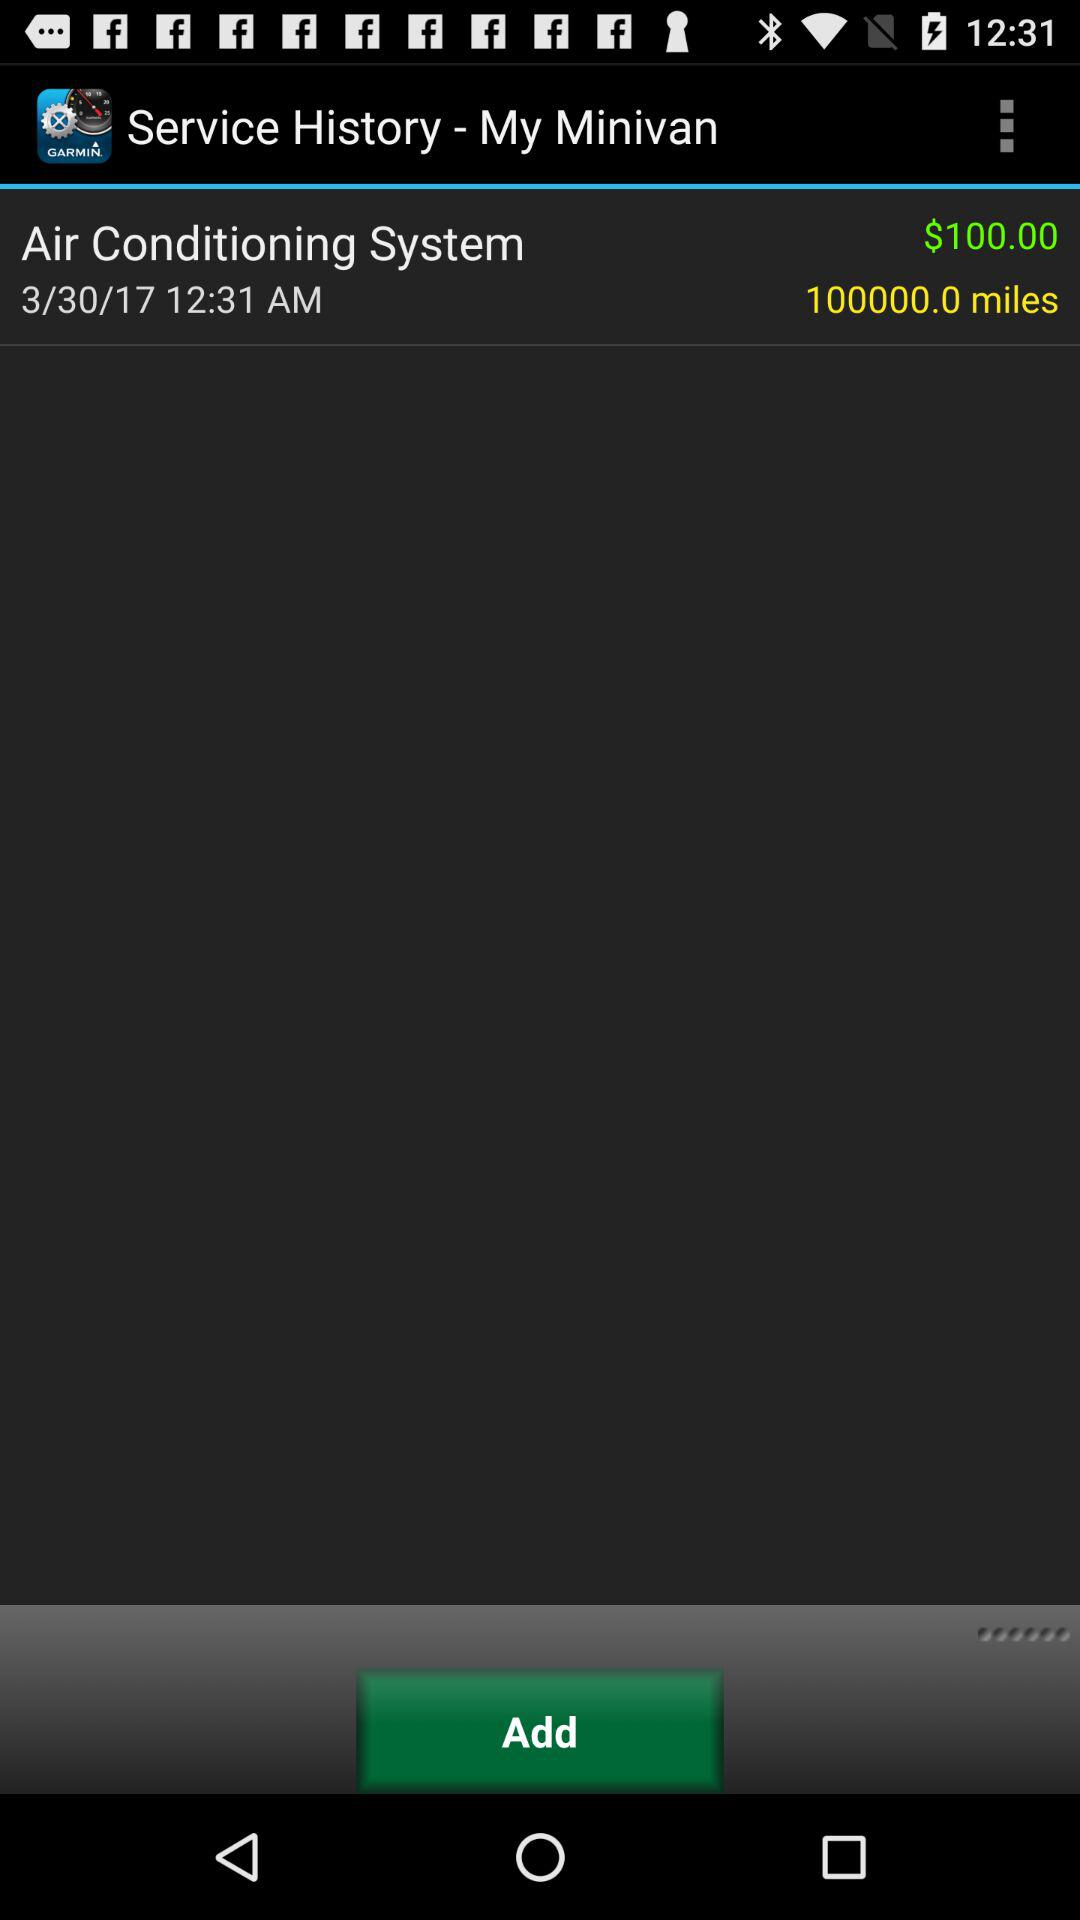What is the service date? The service date is March 30, 2017. 